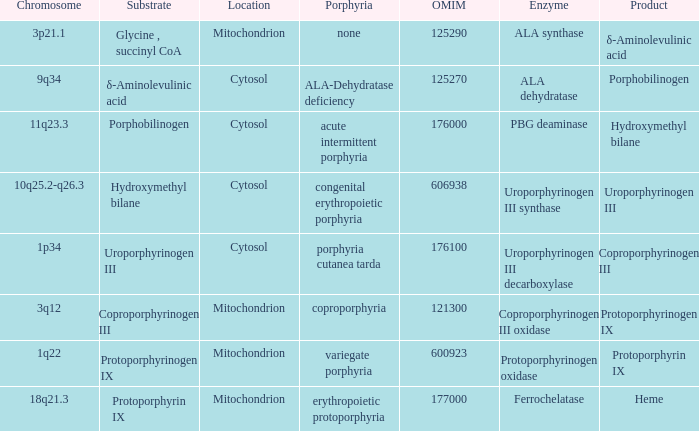What is protoporphyrin ix's substrate? Protoporphyrinogen IX. 